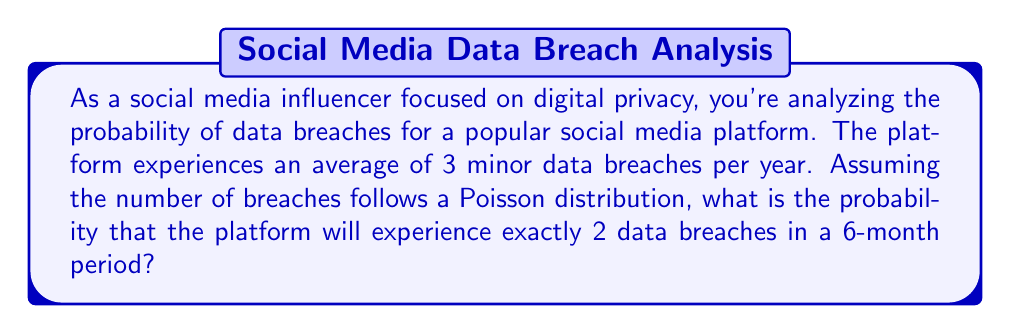What is the answer to this math problem? To solve this problem, we'll use the Poisson distribution formula:

$$P(X = k) = \frac{e^{-\lambda} \lambda^k}{k!}$$

Where:
$P(X = k)$ is the probability of exactly $k$ events occurring
$\lambda$ is the average number of events in the given time period
$e$ is Euler's number (approximately 2.71828)
$k!$ is the factorial of $k$

Steps:
1. Calculate $\lambda$ for a 6-month period:
   $\lambda = 3 \text{ breaches/year} \times \frac{1 \text{ year}}{2} = 1.5 \text{ breaches}$

2. We want the probability of exactly 2 breaches, so $k = 2$

3. Plug these values into the Poisson distribution formula:

   $$P(X = 2) = \frac{e^{-1.5} 1.5^2}{2!}$$

4. Simplify:
   $$P(X = 2) = \frac{e^{-1.5} \times 2.25}{2}$$

5. Calculate:
   $$P(X = 2) \approx \frac{0.22313 \times 2.25}{2} \approx 0.2510$$

Therefore, the probability of exactly 2 data breaches occurring in a 6-month period is approximately 0.2510 or 25.10%.
Answer: $0.2510$ or $25.10\%$ 